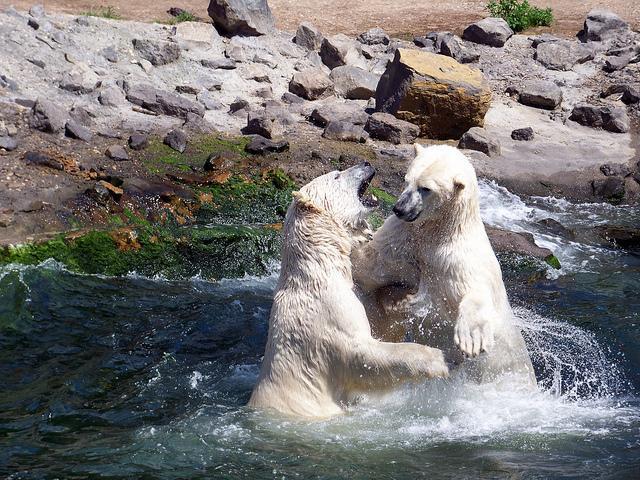How many bears are in the photo?
Give a very brief answer. 2. 